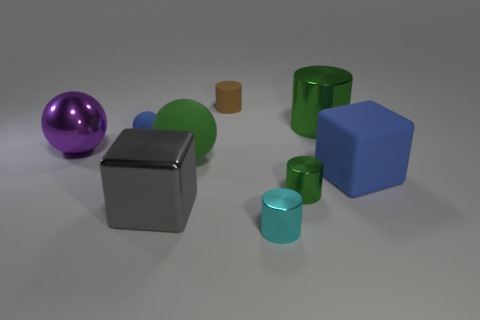What number of other things are the same shape as the small cyan metal object?
Offer a very short reply. 3. What color is the cylinder that is the same size as the gray metallic thing?
Your answer should be very brief. Green. How many blocks are either brown objects or large gray metallic objects?
Provide a short and direct response. 1. How many small cyan blocks are there?
Your response must be concise. 0. There is a big gray thing; is its shape the same as the big matte thing that is to the right of the tiny green metal object?
Offer a terse response. Yes. There is a matte block that is the same color as the tiny sphere; what size is it?
Offer a very short reply. Large. What number of things are green balls or tiny purple matte cylinders?
Your answer should be compact. 1. There is a green shiny object that is behind the blue thing in front of the purple thing; what is its shape?
Ensure brevity in your answer.  Cylinder. Does the big rubber thing that is to the left of the tiny brown rubber object have the same shape as the small cyan metal thing?
Provide a short and direct response. No. There is a cyan cylinder that is the same material as the big gray thing; what is its size?
Make the answer very short. Small. 